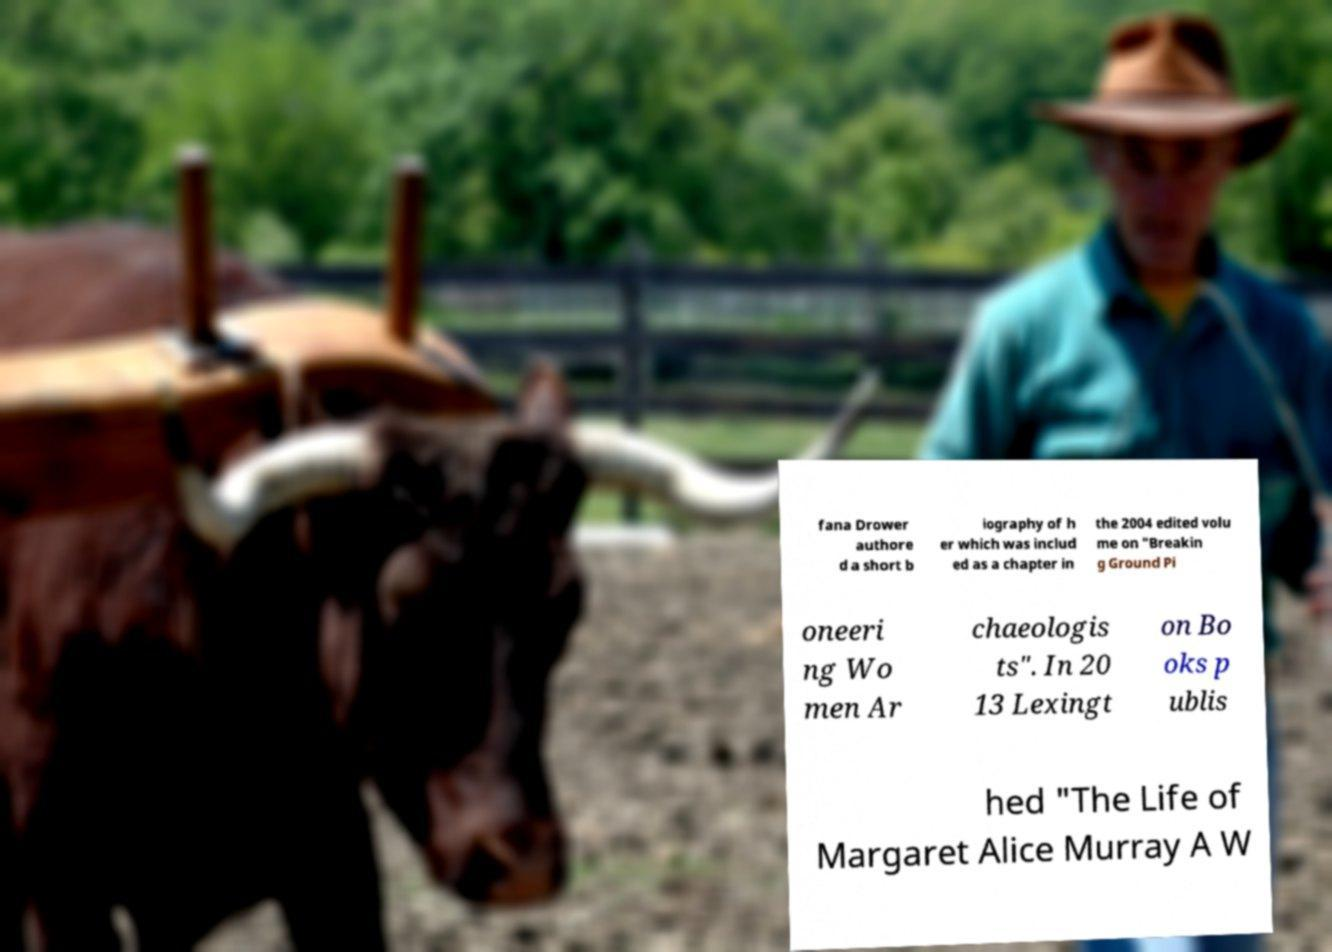What messages or text are displayed in this image? I need them in a readable, typed format. fana Drower authore d a short b iography of h er which was includ ed as a chapter in the 2004 edited volu me on "Breakin g Ground Pi oneeri ng Wo men Ar chaeologis ts". In 20 13 Lexingt on Bo oks p ublis hed "The Life of Margaret Alice Murray A W 